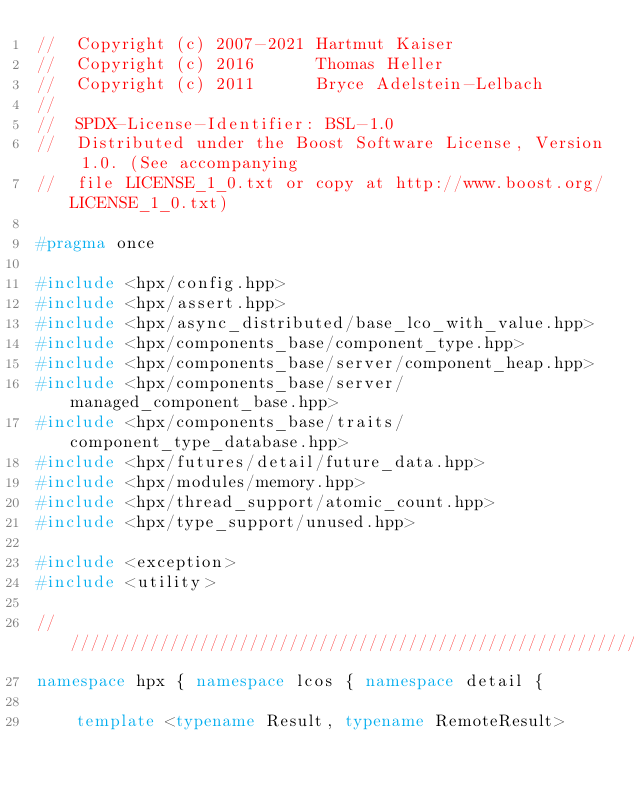Convert code to text. <code><loc_0><loc_0><loc_500><loc_500><_C++_>//  Copyright (c) 2007-2021 Hartmut Kaiser
//  Copyright (c) 2016      Thomas Heller
//  Copyright (c) 2011      Bryce Adelstein-Lelbach
//
//  SPDX-License-Identifier: BSL-1.0
//  Distributed under the Boost Software License, Version 1.0. (See accompanying
//  file LICENSE_1_0.txt or copy at http://www.boost.org/LICENSE_1_0.txt)

#pragma once

#include <hpx/config.hpp>
#include <hpx/assert.hpp>
#include <hpx/async_distributed/base_lco_with_value.hpp>
#include <hpx/components_base/component_type.hpp>
#include <hpx/components_base/server/component_heap.hpp>
#include <hpx/components_base/server/managed_component_base.hpp>
#include <hpx/components_base/traits/component_type_database.hpp>
#include <hpx/futures/detail/future_data.hpp>
#include <hpx/modules/memory.hpp>
#include <hpx/thread_support/atomic_count.hpp>
#include <hpx/type_support/unused.hpp>

#include <exception>
#include <utility>

///////////////////////////////////////////////////////////////////////////////
namespace hpx { namespace lcos { namespace detail {

    template <typename Result, typename RemoteResult></code> 